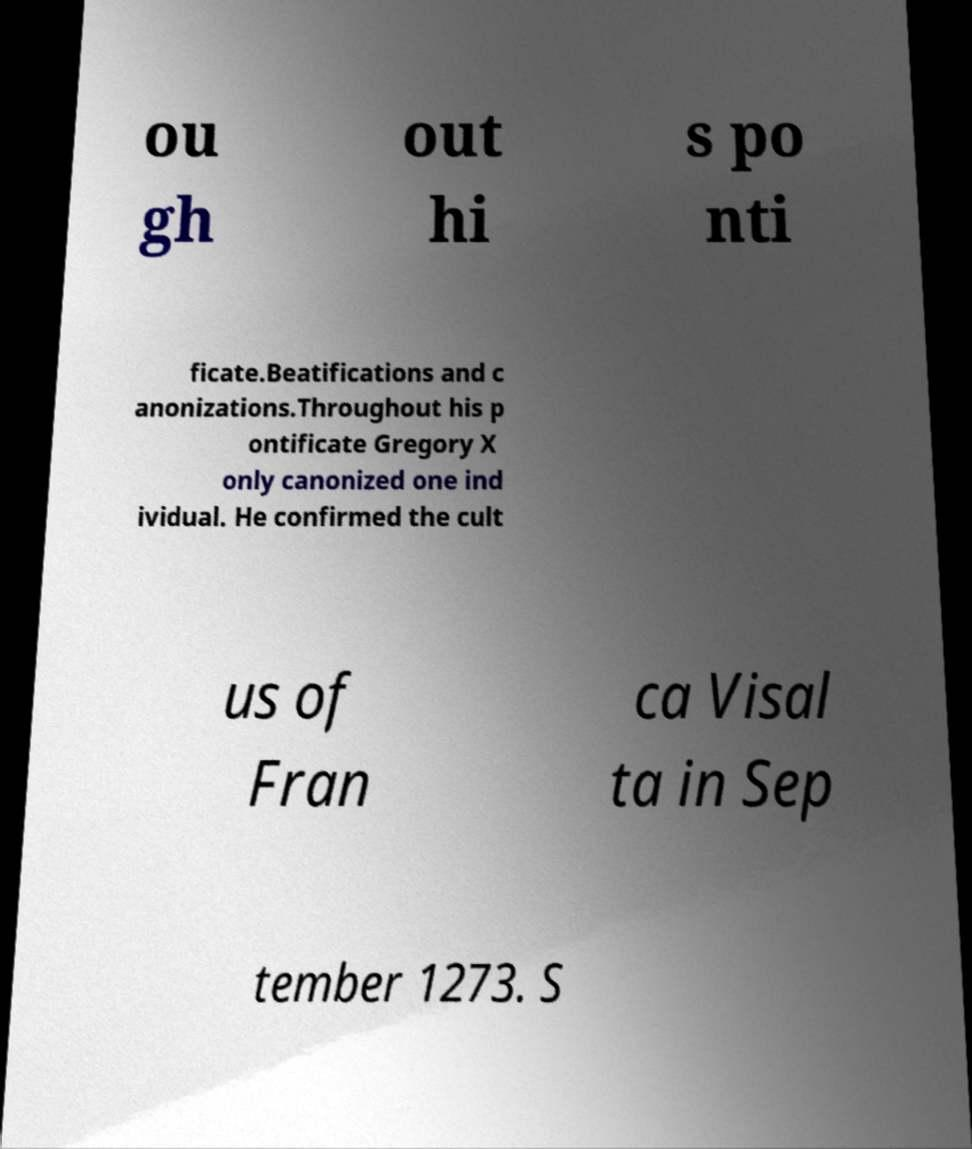For documentation purposes, I need the text within this image transcribed. Could you provide that? ou gh out hi s po nti ficate.Beatifications and c anonizations.Throughout his p ontificate Gregory X only canonized one ind ividual. He confirmed the cult us of Fran ca Visal ta in Sep tember 1273. S 